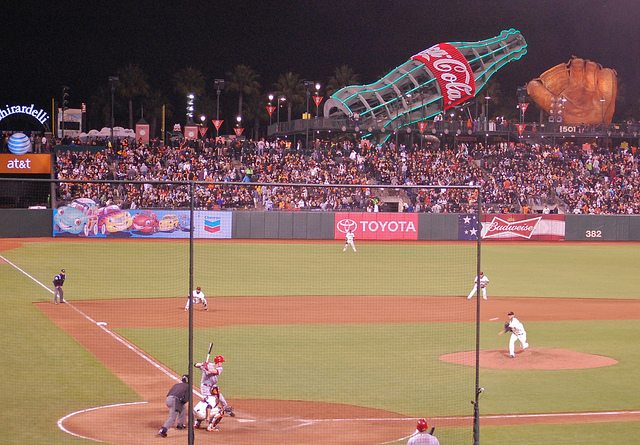<image>Which gasoline company is advertised? I am not certain about the gasoline company advertised. It could possibly be Chevron. Which gasoline company is advertised? The gasoline company that is advertised is Chevron. 